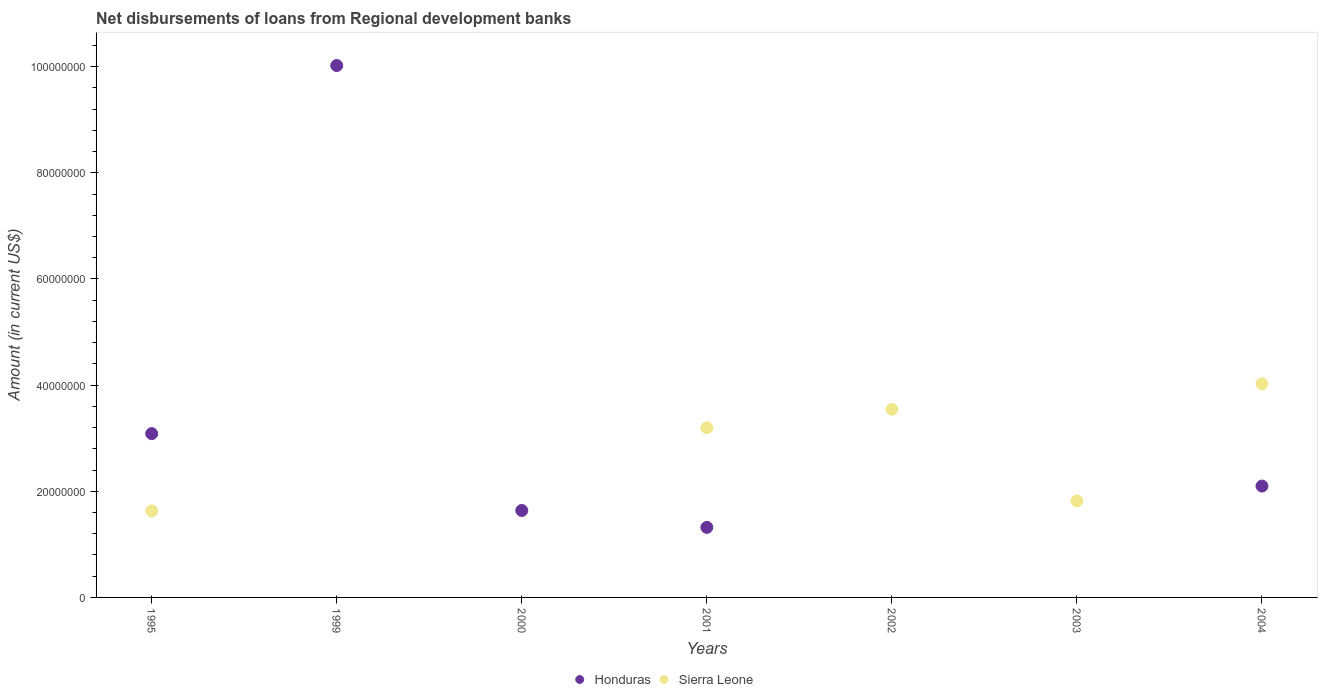How many different coloured dotlines are there?
Provide a short and direct response. 2. Across all years, what is the maximum amount of disbursements of loans from regional development banks in Honduras?
Provide a succinct answer. 1.00e+08. Across all years, what is the minimum amount of disbursements of loans from regional development banks in Honduras?
Keep it short and to the point. 0. In which year was the amount of disbursements of loans from regional development banks in Honduras maximum?
Offer a very short reply. 1999. What is the total amount of disbursements of loans from regional development banks in Honduras in the graph?
Provide a short and direct response. 1.82e+08. What is the difference between the amount of disbursements of loans from regional development banks in Sierra Leone in 1995 and that in 2003?
Your answer should be compact. -1.89e+06. What is the difference between the amount of disbursements of loans from regional development banks in Honduras in 2002 and the amount of disbursements of loans from regional development banks in Sierra Leone in 2001?
Keep it short and to the point. -3.20e+07. What is the average amount of disbursements of loans from regional development banks in Honduras per year?
Offer a very short reply. 2.59e+07. In the year 2004, what is the difference between the amount of disbursements of loans from regional development banks in Honduras and amount of disbursements of loans from regional development banks in Sierra Leone?
Your answer should be very brief. -1.93e+07. In how many years, is the amount of disbursements of loans from regional development banks in Honduras greater than 60000000 US$?
Make the answer very short. 1. What is the ratio of the amount of disbursements of loans from regional development banks in Honduras in 2000 to that in 2004?
Offer a terse response. 0.78. Is the amount of disbursements of loans from regional development banks in Honduras in 2001 less than that in 2004?
Offer a terse response. Yes. Is the difference between the amount of disbursements of loans from regional development banks in Honduras in 2001 and 2004 greater than the difference between the amount of disbursements of loans from regional development banks in Sierra Leone in 2001 and 2004?
Keep it short and to the point. Yes. What is the difference between the highest and the second highest amount of disbursements of loans from regional development banks in Honduras?
Provide a succinct answer. 6.94e+07. What is the difference between the highest and the lowest amount of disbursements of loans from regional development banks in Sierra Leone?
Offer a terse response. 4.02e+07. Does the amount of disbursements of loans from regional development banks in Sierra Leone monotonically increase over the years?
Your answer should be compact. No. Is the amount of disbursements of loans from regional development banks in Sierra Leone strictly greater than the amount of disbursements of loans from regional development banks in Honduras over the years?
Offer a terse response. No. Is the amount of disbursements of loans from regional development banks in Sierra Leone strictly less than the amount of disbursements of loans from regional development banks in Honduras over the years?
Provide a short and direct response. No. What is the difference between two consecutive major ticks on the Y-axis?
Keep it short and to the point. 2.00e+07. Are the values on the major ticks of Y-axis written in scientific E-notation?
Your answer should be very brief. No. Does the graph contain any zero values?
Provide a succinct answer. Yes. Does the graph contain grids?
Ensure brevity in your answer.  No. How many legend labels are there?
Provide a succinct answer. 2. How are the legend labels stacked?
Ensure brevity in your answer.  Horizontal. What is the title of the graph?
Your response must be concise. Net disbursements of loans from Regional development banks. Does "Iran" appear as one of the legend labels in the graph?
Keep it short and to the point. No. What is the Amount (in current US$) in Honduras in 1995?
Your answer should be compact. 3.09e+07. What is the Amount (in current US$) in Sierra Leone in 1995?
Provide a succinct answer. 1.63e+07. What is the Amount (in current US$) in Honduras in 1999?
Provide a succinct answer. 1.00e+08. What is the Amount (in current US$) in Honduras in 2000?
Your answer should be compact. 1.64e+07. What is the Amount (in current US$) in Honduras in 2001?
Your answer should be compact. 1.32e+07. What is the Amount (in current US$) of Sierra Leone in 2001?
Provide a short and direct response. 3.20e+07. What is the Amount (in current US$) of Honduras in 2002?
Keep it short and to the point. 0. What is the Amount (in current US$) in Sierra Leone in 2002?
Keep it short and to the point. 3.54e+07. What is the Amount (in current US$) of Sierra Leone in 2003?
Your answer should be very brief. 1.82e+07. What is the Amount (in current US$) in Honduras in 2004?
Make the answer very short. 2.10e+07. What is the Amount (in current US$) of Sierra Leone in 2004?
Provide a succinct answer. 4.02e+07. Across all years, what is the maximum Amount (in current US$) of Honduras?
Give a very brief answer. 1.00e+08. Across all years, what is the maximum Amount (in current US$) of Sierra Leone?
Give a very brief answer. 4.02e+07. Across all years, what is the minimum Amount (in current US$) of Honduras?
Your response must be concise. 0. Across all years, what is the minimum Amount (in current US$) in Sierra Leone?
Your answer should be compact. 0. What is the total Amount (in current US$) in Honduras in the graph?
Offer a very short reply. 1.82e+08. What is the total Amount (in current US$) in Sierra Leone in the graph?
Your response must be concise. 1.42e+08. What is the difference between the Amount (in current US$) in Honduras in 1995 and that in 1999?
Provide a short and direct response. -6.94e+07. What is the difference between the Amount (in current US$) of Honduras in 1995 and that in 2000?
Ensure brevity in your answer.  1.45e+07. What is the difference between the Amount (in current US$) of Honduras in 1995 and that in 2001?
Give a very brief answer. 1.77e+07. What is the difference between the Amount (in current US$) of Sierra Leone in 1995 and that in 2001?
Your answer should be very brief. -1.57e+07. What is the difference between the Amount (in current US$) of Sierra Leone in 1995 and that in 2002?
Your answer should be very brief. -1.91e+07. What is the difference between the Amount (in current US$) in Sierra Leone in 1995 and that in 2003?
Offer a terse response. -1.89e+06. What is the difference between the Amount (in current US$) in Honduras in 1995 and that in 2004?
Offer a terse response. 9.88e+06. What is the difference between the Amount (in current US$) of Sierra Leone in 1995 and that in 2004?
Your answer should be very brief. -2.39e+07. What is the difference between the Amount (in current US$) of Honduras in 1999 and that in 2000?
Provide a short and direct response. 8.38e+07. What is the difference between the Amount (in current US$) of Honduras in 1999 and that in 2001?
Ensure brevity in your answer.  8.70e+07. What is the difference between the Amount (in current US$) in Honduras in 1999 and that in 2004?
Your response must be concise. 7.92e+07. What is the difference between the Amount (in current US$) in Honduras in 2000 and that in 2001?
Make the answer very short. 3.18e+06. What is the difference between the Amount (in current US$) of Honduras in 2000 and that in 2004?
Provide a succinct answer. -4.60e+06. What is the difference between the Amount (in current US$) in Sierra Leone in 2001 and that in 2002?
Offer a terse response. -3.47e+06. What is the difference between the Amount (in current US$) of Sierra Leone in 2001 and that in 2003?
Your answer should be very brief. 1.38e+07. What is the difference between the Amount (in current US$) in Honduras in 2001 and that in 2004?
Your response must be concise. -7.78e+06. What is the difference between the Amount (in current US$) of Sierra Leone in 2001 and that in 2004?
Your answer should be very brief. -8.27e+06. What is the difference between the Amount (in current US$) of Sierra Leone in 2002 and that in 2003?
Your answer should be very brief. 1.73e+07. What is the difference between the Amount (in current US$) of Sierra Leone in 2002 and that in 2004?
Provide a short and direct response. -4.79e+06. What is the difference between the Amount (in current US$) of Sierra Leone in 2003 and that in 2004?
Offer a very short reply. -2.21e+07. What is the difference between the Amount (in current US$) in Honduras in 1995 and the Amount (in current US$) in Sierra Leone in 2001?
Make the answer very short. -1.11e+06. What is the difference between the Amount (in current US$) in Honduras in 1995 and the Amount (in current US$) in Sierra Leone in 2002?
Keep it short and to the point. -4.58e+06. What is the difference between the Amount (in current US$) in Honduras in 1995 and the Amount (in current US$) in Sierra Leone in 2003?
Your answer should be very brief. 1.27e+07. What is the difference between the Amount (in current US$) in Honduras in 1995 and the Amount (in current US$) in Sierra Leone in 2004?
Give a very brief answer. -9.38e+06. What is the difference between the Amount (in current US$) of Honduras in 1999 and the Amount (in current US$) of Sierra Leone in 2001?
Provide a short and direct response. 6.82e+07. What is the difference between the Amount (in current US$) of Honduras in 1999 and the Amount (in current US$) of Sierra Leone in 2002?
Provide a succinct answer. 6.48e+07. What is the difference between the Amount (in current US$) in Honduras in 1999 and the Amount (in current US$) in Sierra Leone in 2003?
Give a very brief answer. 8.20e+07. What is the difference between the Amount (in current US$) of Honduras in 1999 and the Amount (in current US$) of Sierra Leone in 2004?
Provide a succinct answer. 6.00e+07. What is the difference between the Amount (in current US$) of Honduras in 2000 and the Amount (in current US$) of Sierra Leone in 2001?
Your answer should be very brief. -1.56e+07. What is the difference between the Amount (in current US$) in Honduras in 2000 and the Amount (in current US$) in Sierra Leone in 2002?
Give a very brief answer. -1.91e+07. What is the difference between the Amount (in current US$) in Honduras in 2000 and the Amount (in current US$) in Sierra Leone in 2003?
Your answer should be very brief. -1.80e+06. What is the difference between the Amount (in current US$) in Honduras in 2000 and the Amount (in current US$) in Sierra Leone in 2004?
Your answer should be compact. -2.39e+07. What is the difference between the Amount (in current US$) of Honduras in 2001 and the Amount (in current US$) of Sierra Leone in 2002?
Provide a short and direct response. -2.22e+07. What is the difference between the Amount (in current US$) of Honduras in 2001 and the Amount (in current US$) of Sierra Leone in 2003?
Offer a terse response. -4.98e+06. What is the difference between the Amount (in current US$) of Honduras in 2001 and the Amount (in current US$) of Sierra Leone in 2004?
Your answer should be compact. -2.70e+07. What is the average Amount (in current US$) in Honduras per year?
Your answer should be compact. 2.59e+07. What is the average Amount (in current US$) in Sierra Leone per year?
Your answer should be very brief. 2.03e+07. In the year 1995, what is the difference between the Amount (in current US$) of Honduras and Amount (in current US$) of Sierra Leone?
Your answer should be very brief. 1.46e+07. In the year 2001, what is the difference between the Amount (in current US$) in Honduras and Amount (in current US$) in Sierra Leone?
Offer a very short reply. -1.88e+07. In the year 2004, what is the difference between the Amount (in current US$) in Honduras and Amount (in current US$) in Sierra Leone?
Your answer should be very brief. -1.93e+07. What is the ratio of the Amount (in current US$) in Honduras in 1995 to that in 1999?
Your answer should be very brief. 0.31. What is the ratio of the Amount (in current US$) of Honduras in 1995 to that in 2000?
Ensure brevity in your answer.  1.88. What is the ratio of the Amount (in current US$) of Honduras in 1995 to that in 2001?
Your answer should be very brief. 2.34. What is the ratio of the Amount (in current US$) in Sierra Leone in 1995 to that in 2001?
Provide a short and direct response. 0.51. What is the ratio of the Amount (in current US$) of Sierra Leone in 1995 to that in 2002?
Offer a terse response. 0.46. What is the ratio of the Amount (in current US$) in Sierra Leone in 1995 to that in 2003?
Your answer should be very brief. 0.9. What is the ratio of the Amount (in current US$) of Honduras in 1995 to that in 2004?
Offer a terse response. 1.47. What is the ratio of the Amount (in current US$) in Sierra Leone in 1995 to that in 2004?
Provide a short and direct response. 0.41. What is the ratio of the Amount (in current US$) of Honduras in 1999 to that in 2000?
Your response must be concise. 6.12. What is the ratio of the Amount (in current US$) in Honduras in 1999 to that in 2001?
Provide a succinct answer. 7.59. What is the ratio of the Amount (in current US$) of Honduras in 1999 to that in 2004?
Provide a short and direct response. 4.78. What is the ratio of the Amount (in current US$) of Honduras in 2000 to that in 2001?
Keep it short and to the point. 1.24. What is the ratio of the Amount (in current US$) in Honduras in 2000 to that in 2004?
Your answer should be compact. 0.78. What is the ratio of the Amount (in current US$) of Sierra Leone in 2001 to that in 2002?
Offer a terse response. 0.9. What is the ratio of the Amount (in current US$) in Sierra Leone in 2001 to that in 2003?
Keep it short and to the point. 1.76. What is the ratio of the Amount (in current US$) of Honduras in 2001 to that in 2004?
Your answer should be very brief. 0.63. What is the ratio of the Amount (in current US$) in Sierra Leone in 2001 to that in 2004?
Your answer should be very brief. 0.79. What is the ratio of the Amount (in current US$) of Sierra Leone in 2002 to that in 2003?
Your response must be concise. 1.95. What is the ratio of the Amount (in current US$) of Sierra Leone in 2002 to that in 2004?
Give a very brief answer. 0.88. What is the ratio of the Amount (in current US$) in Sierra Leone in 2003 to that in 2004?
Your answer should be very brief. 0.45. What is the difference between the highest and the second highest Amount (in current US$) in Honduras?
Provide a succinct answer. 6.94e+07. What is the difference between the highest and the second highest Amount (in current US$) in Sierra Leone?
Give a very brief answer. 4.79e+06. What is the difference between the highest and the lowest Amount (in current US$) in Honduras?
Ensure brevity in your answer.  1.00e+08. What is the difference between the highest and the lowest Amount (in current US$) of Sierra Leone?
Your response must be concise. 4.02e+07. 